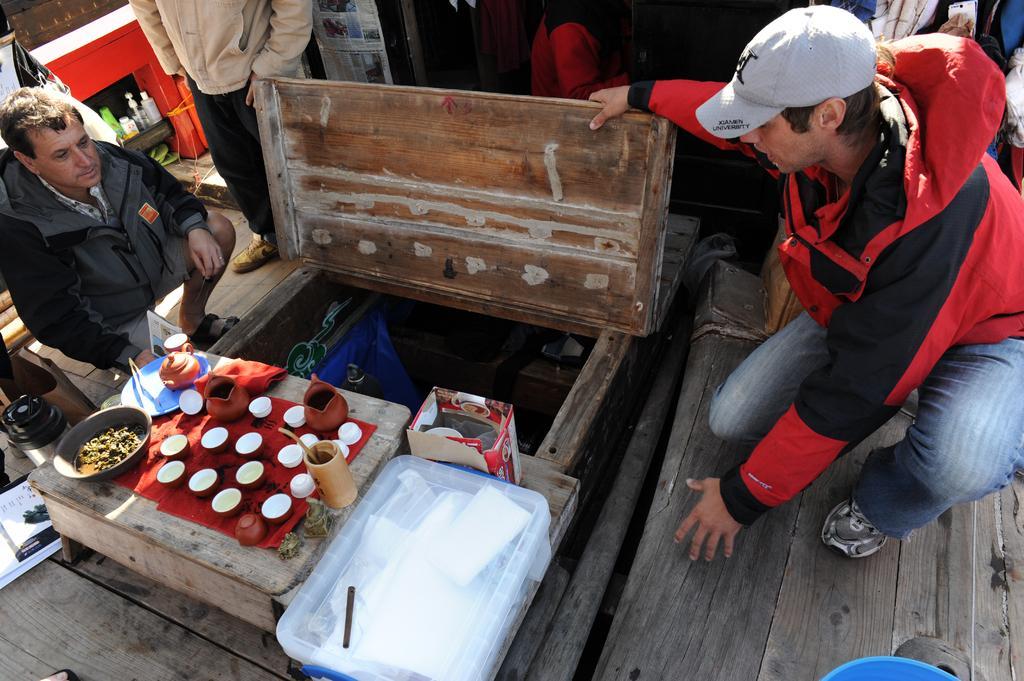Could you give a brief overview of what you see in this image? In this image I can see a person wearing red and black colored jacket, blue jeans, footwear and hat is sitting on the surface and another person wearing jacket and short is sitting on the floor. I can see the wooden surface on which I can see a bowl, a container and few other objects. I can see a transparent box ,a cardboard box and few other objects. In the background I can see few other persons. 